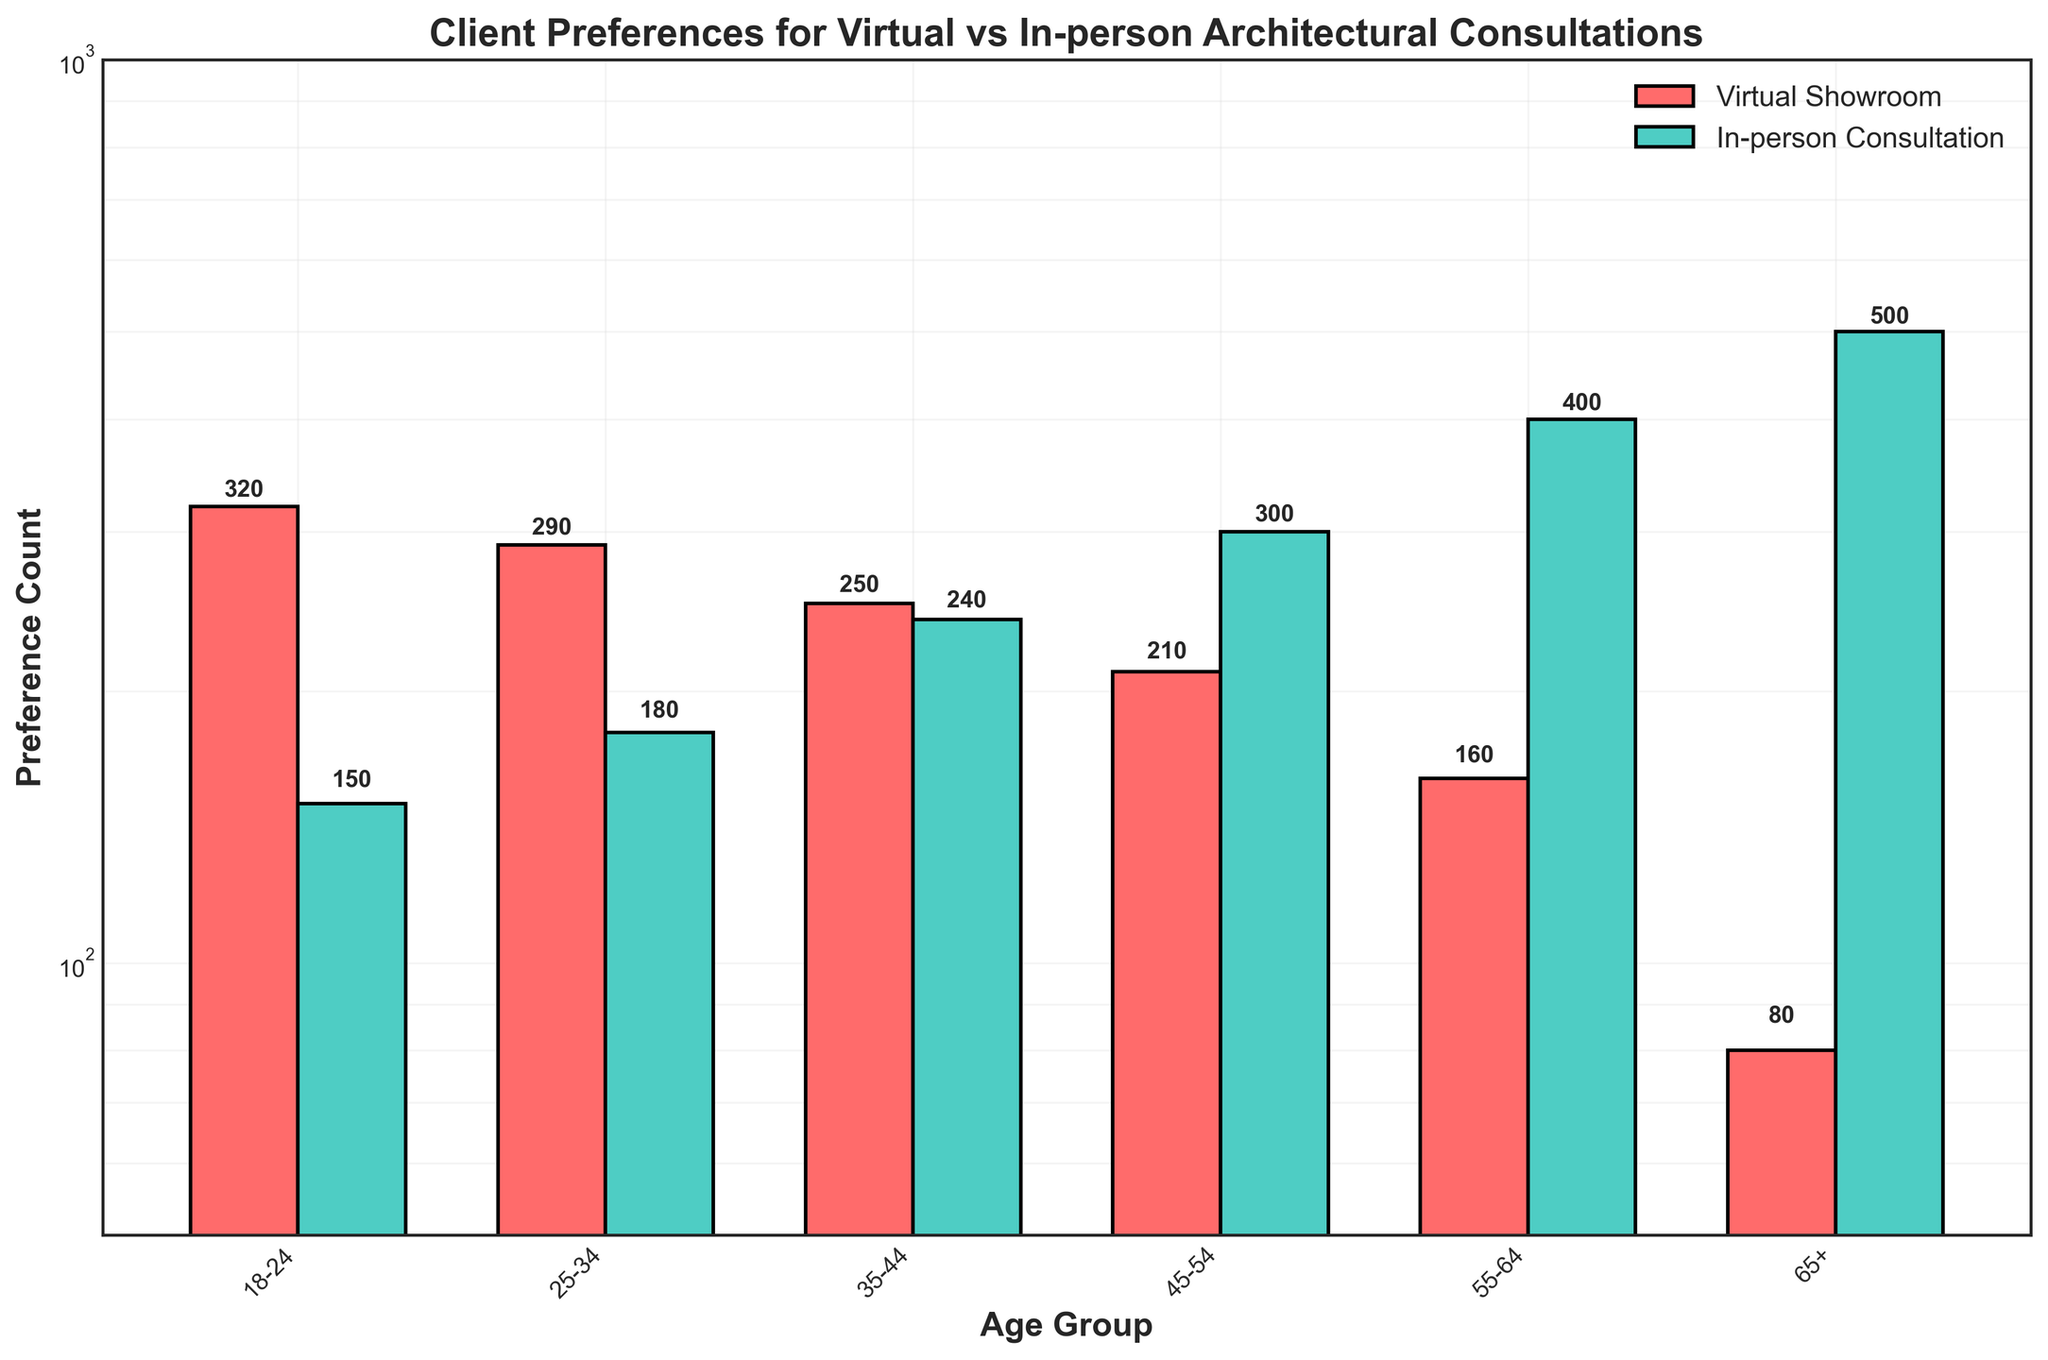What is the title of the plot? The title is typically found at the top of the plot and is used to describe what the plot is about. In this plot, the title is "Client Preferences for Virtual vs In-person Architectural Consultations."
Answer: Client Preferences for Virtual vs In-person Architectural Consultations How many age groups are represented in the plot? To find the number of age groups, count the distinct labeled categories on the x-axis. In this plot, the age groups are 18-24, 25-34, 35-44, 45-54, 55-64, and 65+.
Answer: 6 Which age group has the highest preference for in-person consultations? Look for the highest bar in the "In-person Consultation" category. The 65+ age group has the tallest bar among the in-person preferences.
Answer: 65+ What is the preference count for virtual showrooms in the 25-34 age group? Locate the bar corresponding to the 25-34 age group under the "Virtual Showroom" category and read the value indicated beside or on top of the bar.
Answer: 290 What is the difference in preference counts for in-person consultations between the 45-54 and 55-64 age groups? Subtract the preference count of in-person consultations for the 55-64 age group (400) from that for the 45-54 age group (300).
Answer: 100 What is the ratio of virtual showroom preference to in-person consultation preference for the 18-24 age group? Divide the number of virtual showroom preferences (320) by the number of in-person consultations (150) for the 18-24 age group.
Answer: 2.13 Which age group has a closer preference count between virtual and in-person consultations? Compare the differences between virtual showroom and in-person consultation preferences for each age group. The 35-44 age group has values of 250 (virtual) and 240 (in-person), making the difference smallest among the groups.
Answer: 35-44 How does the preference for virtual showrooms change as the age group increases? Observe the trend of the bar heights for virtual showrooms across increasing age groups from left to right. The preference count for virtual showrooms decreases as the age group increases.
Answer: Decreases What is the sum of preferences for virtual showrooms for the 18-24 and 55-64 age groups? Add the preference counts for virtual showrooms for the 18-24 (320) and 55-64 (160) age groups.
Answer: 480 Why might the plot use a logarithmic scale for the y-axis? A logarithmic scale can help manage a wide range of values and make visual comparisons easier, especially when dealing with data that spans several orders of magnitude. The preferences range from 80 to 500, so a logarithmic scale makes differences more visually interpretable.
Answer: To manage wide range and enhance visual comparisons 